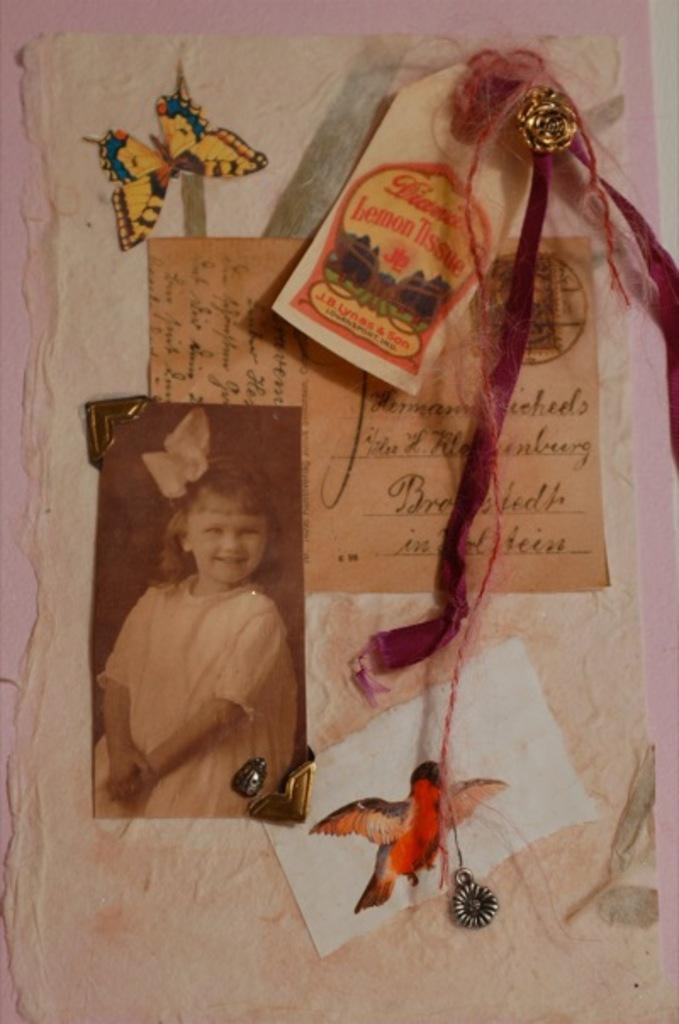What is the main subject of the image? There is a photo of a girl in the image. What other items can be seen in the image besides the girl? There is a card with text and an artificial butterfly in the image. Can you describe the card with text? The card with text is a separate object in the image. Are there any other objects present in the image? Yes, there are other objects present in the image. What route does the girl take to her partner's house in the image? There is no information about a route or a partner's house in the image. The image only shows a photo of a girl, a card with text, and an artificial butterfly. 